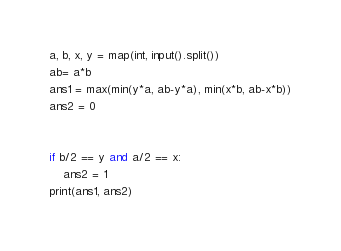<code> <loc_0><loc_0><loc_500><loc_500><_Python_>a, b, x, y = map(int, input().split())
ab= a*b
ans1 = max(min(y*a, ab-y*a), min(x*b, ab-x*b))
ans2 = 0


if b/2 == y and a/2 == x:
    ans2 = 1
print(ans1, ans2)</code> 